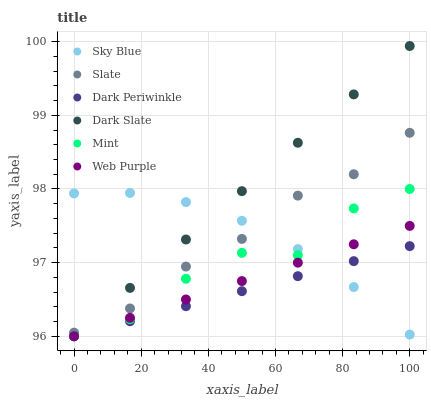Does Dark Periwinkle have the minimum area under the curve?
Answer yes or no. Yes. Does Dark Slate have the maximum area under the curve?
Answer yes or no. Yes. Does Web Purple have the minimum area under the curve?
Answer yes or no. No. Does Web Purple have the maximum area under the curve?
Answer yes or no. No. Is Dark Periwinkle the smoothest?
Answer yes or no. Yes. Is Mint the roughest?
Answer yes or no. Yes. Is Dark Slate the smoothest?
Answer yes or no. No. Is Dark Slate the roughest?
Answer yes or no. No. Does Dark Slate have the lowest value?
Answer yes or no. Yes. Does Sky Blue have the lowest value?
Answer yes or no. No. Does Dark Slate have the highest value?
Answer yes or no. Yes. Does Web Purple have the highest value?
Answer yes or no. No. Is Dark Periwinkle less than Slate?
Answer yes or no. Yes. Is Slate greater than Web Purple?
Answer yes or no. Yes. Does Web Purple intersect Mint?
Answer yes or no. Yes. Is Web Purple less than Mint?
Answer yes or no. No. Is Web Purple greater than Mint?
Answer yes or no. No. Does Dark Periwinkle intersect Slate?
Answer yes or no. No. 